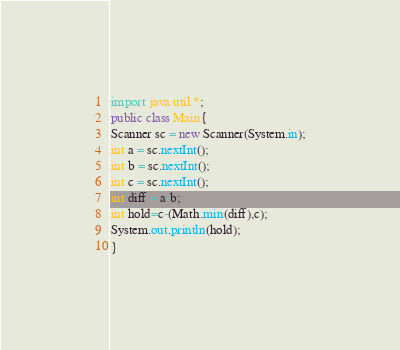<code> <loc_0><loc_0><loc_500><loc_500><_Java_>import java.util.*;
public class Main{
Scanner sc = new Scanner(System.in);
int a = sc.nextInt();
int b = sc.nextInt();
int c = sc.nextInt();
int diff = a-b;
int hold=c-(Math.min(diff),c);
System.out.println(hold);
}
</code> 